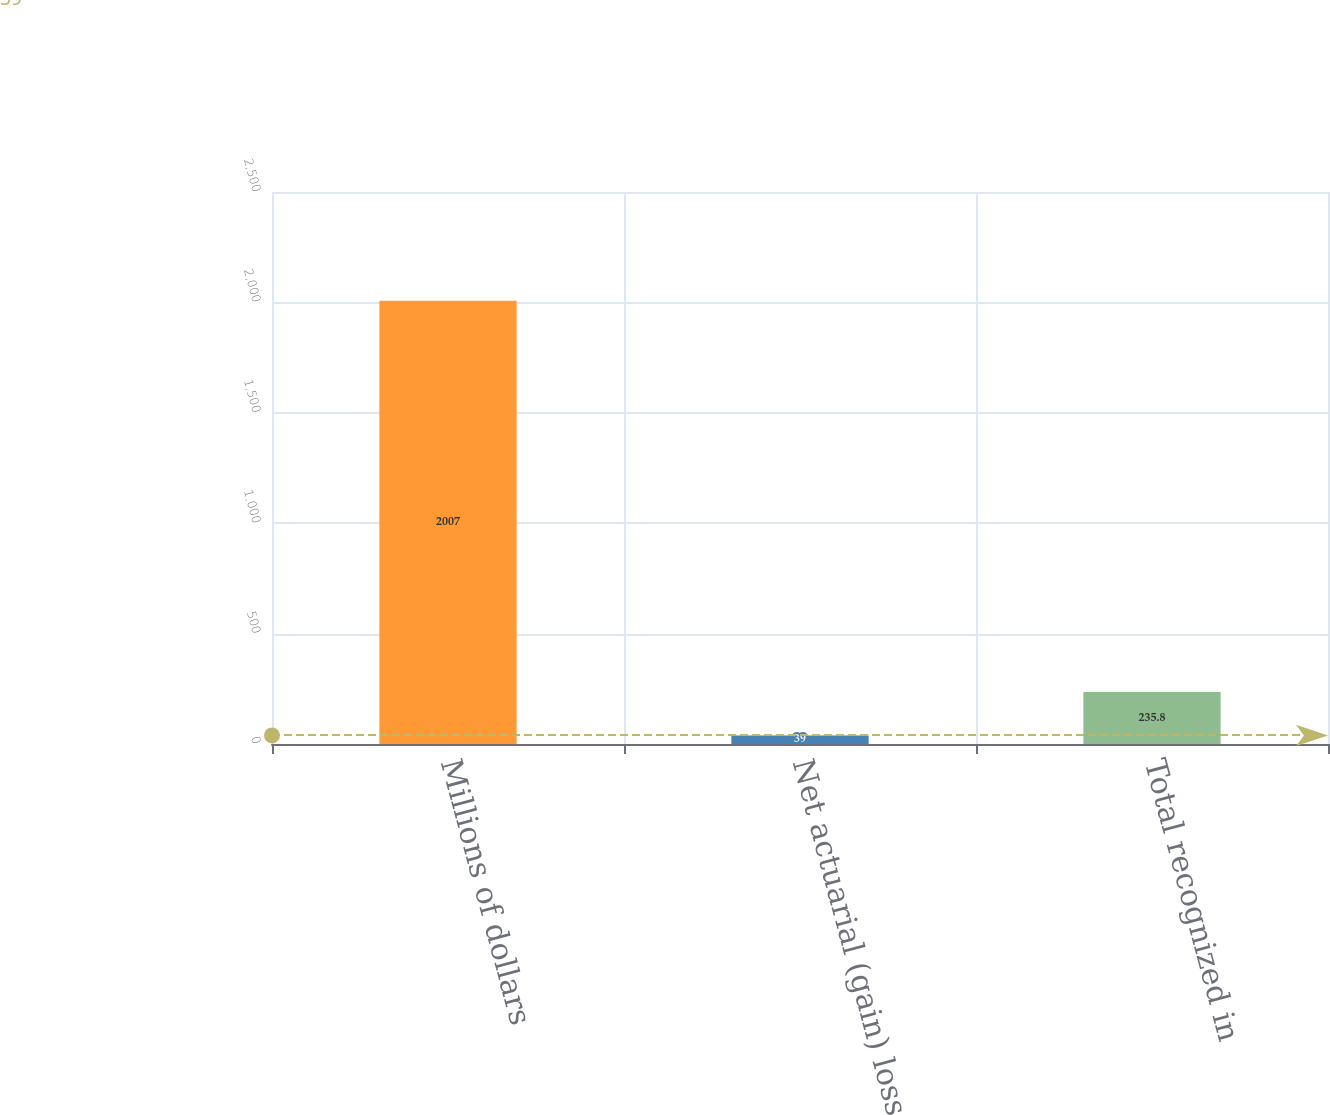Convert chart to OTSL. <chart><loc_0><loc_0><loc_500><loc_500><bar_chart><fcel>Millions of dollars<fcel>Net actuarial (gain) loss<fcel>Total recognized in<nl><fcel>2007<fcel>39<fcel>235.8<nl></chart> 